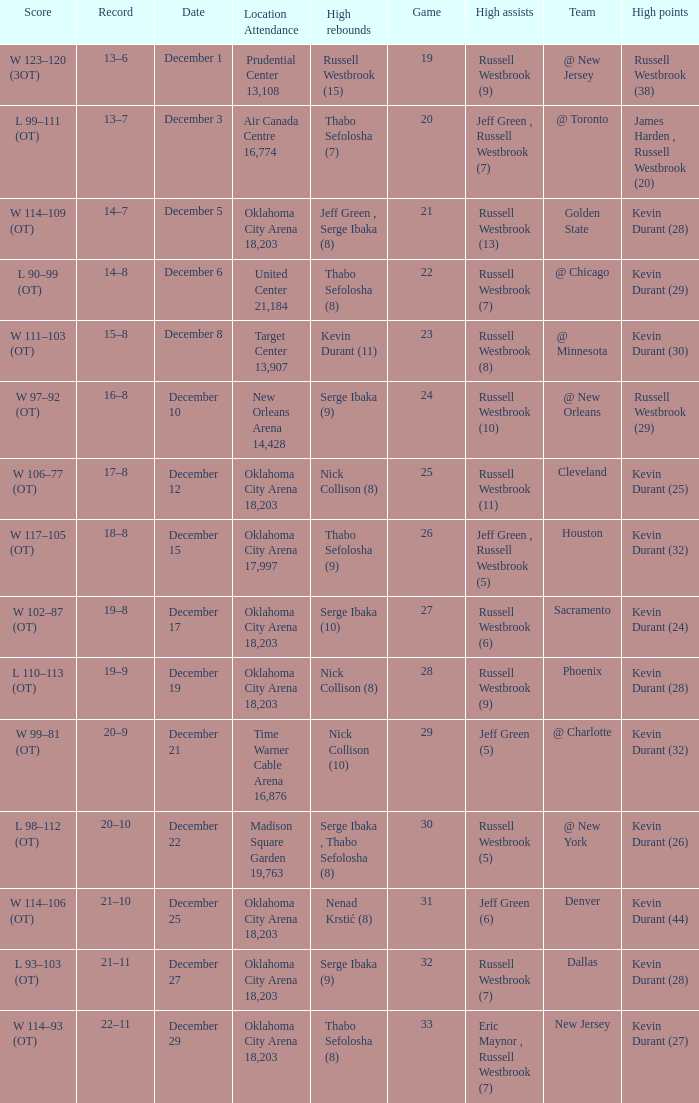Who had the high rebounds record on December 12? Nick Collison (8). 